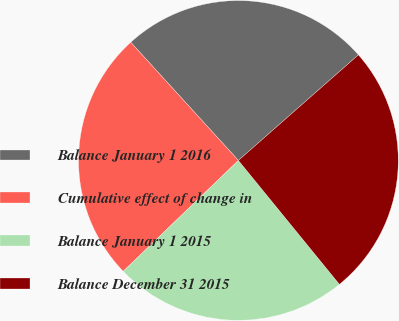<chart> <loc_0><loc_0><loc_500><loc_500><pie_chart><fcel>Balance January 1 2016<fcel>Cumulative effect of change in<fcel>Balance January 1 2015<fcel>Balance December 31 2015<nl><fcel>25.28%<fcel>25.44%<fcel>23.69%<fcel>25.6%<nl></chart> 